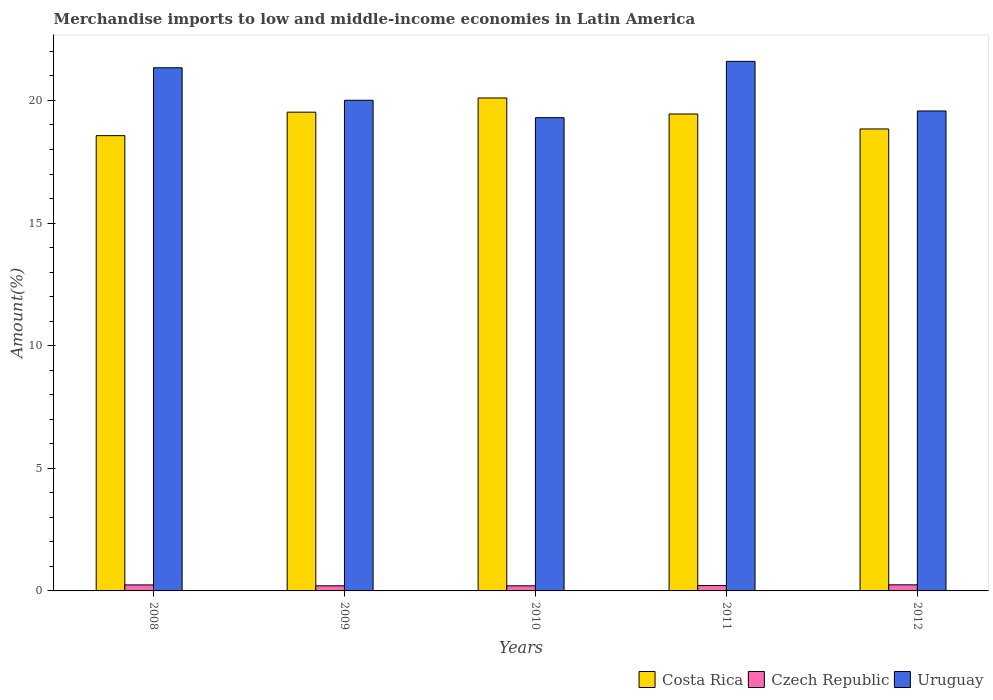How many bars are there on the 4th tick from the left?
Make the answer very short. 3. How many bars are there on the 3rd tick from the right?
Keep it short and to the point. 3. What is the label of the 3rd group of bars from the left?
Your response must be concise. 2010. In how many cases, is the number of bars for a given year not equal to the number of legend labels?
Make the answer very short. 0. What is the percentage of amount earned from merchandise imports in Costa Rica in 2010?
Provide a short and direct response. 20.1. Across all years, what is the maximum percentage of amount earned from merchandise imports in Czech Republic?
Your response must be concise. 0.25. Across all years, what is the minimum percentage of amount earned from merchandise imports in Uruguay?
Provide a short and direct response. 19.3. In which year was the percentage of amount earned from merchandise imports in Costa Rica minimum?
Your response must be concise. 2008. What is the total percentage of amount earned from merchandise imports in Costa Rica in the graph?
Offer a terse response. 96.47. What is the difference between the percentage of amount earned from merchandise imports in Costa Rica in 2011 and that in 2012?
Keep it short and to the point. 0.61. What is the difference between the percentage of amount earned from merchandise imports in Uruguay in 2010 and the percentage of amount earned from merchandise imports in Costa Rica in 2009?
Your answer should be compact. -0.22. What is the average percentage of amount earned from merchandise imports in Costa Rica per year?
Your answer should be compact. 19.29. In the year 2011, what is the difference between the percentage of amount earned from merchandise imports in Costa Rica and percentage of amount earned from merchandise imports in Uruguay?
Provide a succinct answer. -2.15. In how many years, is the percentage of amount earned from merchandise imports in Czech Republic greater than 11 %?
Make the answer very short. 0. What is the ratio of the percentage of amount earned from merchandise imports in Czech Republic in 2011 to that in 2012?
Ensure brevity in your answer.  0.89. Is the percentage of amount earned from merchandise imports in Uruguay in 2011 less than that in 2012?
Offer a terse response. No. What is the difference between the highest and the second highest percentage of amount earned from merchandise imports in Costa Rica?
Your answer should be very brief. 0.58. What is the difference between the highest and the lowest percentage of amount earned from merchandise imports in Costa Rica?
Give a very brief answer. 1.54. In how many years, is the percentage of amount earned from merchandise imports in Uruguay greater than the average percentage of amount earned from merchandise imports in Uruguay taken over all years?
Your response must be concise. 2. What does the 3rd bar from the left in 2012 represents?
Make the answer very short. Uruguay. What does the 2nd bar from the right in 2009 represents?
Your answer should be very brief. Czech Republic. Is it the case that in every year, the sum of the percentage of amount earned from merchandise imports in Costa Rica and percentage of amount earned from merchandise imports in Uruguay is greater than the percentage of amount earned from merchandise imports in Czech Republic?
Provide a succinct answer. Yes. How many bars are there?
Keep it short and to the point. 15. Are all the bars in the graph horizontal?
Your answer should be very brief. No. How many legend labels are there?
Your answer should be very brief. 3. What is the title of the graph?
Give a very brief answer. Merchandise imports to low and middle-income economies in Latin America. What is the label or title of the Y-axis?
Offer a very short reply. Amount(%). What is the Amount(%) in Costa Rica in 2008?
Offer a very short reply. 18.56. What is the Amount(%) in Czech Republic in 2008?
Give a very brief answer. 0.24. What is the Amount(%) of Uruguay in 2008?
Make the answer very short. 21.33. What is the Amount(%) in Costa Rica in 2009?
Keep it short and to the point. 19.52. What is the Amount(%) of Czech Republic in 2009?
Your response must be concise. 0.21. What is the Amount(%) in Uruguay in 2009?
Ensure brevity in your answer.  20.01. What is the Amount(%) of Costa Rica in 2010?
Keep it short and to the point. 20.1. What is the Amount(%) in Czech Republic in 2010?
Your response must be concise. 0.21. What is the Amount(%) of Uruguay in 2010?
Offer a terse response. 19.3. What is the Amount(%) in Costa Rica in 2011?
Your response must be concise. 19.45. What is the Amount(%) in Czech Republic in 2011?
Ensure brevity in your answer.  0.22. What is the Amount(%) of Uruguay in 2011?
Offer a very short reply. 21.59. What is the Amount(%) of Costa Rica in 2012?
Provide a short and direct response. 18.84. What is the Amount(%) in Czech Republic in 2012?
Your answer should be compact. 0.25. What is the Amount(%) in Uruguay in 2012?
Your answer should be compact. 19.57. Across all years, what is the maximum Amount(%) in Costa Rica?
Provide a short and direct response. 20.1. Across all years, what is the maximum Amount(%) of Czech Republic?
Your response must be concise. 0.25. Across all years, what is the maximum Amount(%) in Uruguay?
Make the answer very short. 21.59. Across all years, what is the minimum Amount(%) in Costa Rica?
Keep it short and to the point. 18.56. Across all years, what is the minimum Amount(%) of Czech Republic?
Your response must be concise. 0.21. Across all years, what is the minimum Amount(%) of Uruguay?
Give a very brief answer. 19.3. What is the total Amount(%) of Costa Rica in the graph?
Give a very brief answer. 96.47. What is the total Amount(%) in Czech Republic in the graph?
Provide a succinct answer. 1.13. What is the total Amount(%) in Uruguay in the graph?
Offer a very short reply. 101.8. What is the difference between the Amount(%) in Costa Rica in 2008 and that in 2009?
Offer a terse response. -0.96. What is the difference between the Amount(%) in Czech Republic in 2008 and that in 2009?
Your answer should be compact. 0.04. What is the difference between the Amount(%) of Uruguay in 2008 and that in 2009?
Keep it short and to the point. 1.33. What is the difference between the Amount(%) in Costa Rica in 2008 and that in 2010?
Offer a terse response. -1.54. What is the difference between the Amount(%) in Czech Republic in 2008 and that in 2010?
Your answer should be compact. 0.04. What is the difference between the Amount(%) of Uruguay in 2008 and that in 2010?
Your answer should be compact. 2.04. What is the difference between the Amount(%) in Costa Rica in 2008 and that in 2011?
Ensure brevity in your answer.  -0.88. What is the difference between the Amount(%) of Czech Republic in 2008 and that in 2011?
Your answer should be very brief. 0.02. What is the difference between the Amount(%) in Uruguay in 2008 and that in 2011?
Provide a short and direct response. -0.26. What is the difference between the Amount(%) in Costa Rica in 2008 and that in 2012?
Offer a terse response. -0.27. What is the difference between the Amount(%) in Czech Republic in 2008 and that in 2012?
Keep it short and to the point. -0. What is the difference between the Amount(%) in Uruguay in 2008 and that in 2012?
Provide a short and direct response. 1.76. What is the difference between the Amount(%) in Costa Rica in 2009 and that in 2010?
Give a very brief answer. -0.58. What is the difference between the Amount(%) of Czech Republic in 2009 and that in 2010?
Give a very brief answer. 0. What is the difference between the Amount(%) in Uruguay in 2009 and that in 2010?
Give a very brief answer. 0.71. What is the difference between the Amount(%) in Costa Rica in 2009 and that in 2011?
Keep it short and to the point. 0.07. What is the difference between the Amount(%) in Czech Republic in 2009 and that in 2011?
Ensure brevity in your answer.  -0.01. What is the difference between the Amount(%) of Uruguay in 2009 and that in 2011?
Ensure brevity in your answer.  -1.59. What is the difference between the Amount(%) of Costa Rica in 2009 and that in 2012?
Provide a succinct answer. 0.68. What is the difference between the Amount(%) in Czech Republic in 2009 and that in 2012?
Your answer should be very brief. -0.04. What is the difference between the Amount(%) in Uruguay in 2009 and that in 2012?
Ensure brevity in your answer.  0.44. What is the difference between the Amount(%) in Costa Rica in 2010 and that in 2011?
Keep it short and to the point. 0.65. What is the difference between the Amount(%) of Czech Republic in 2010 and that in 2011?
Make the answer very short. -0.01. What is the difference between the Amount(%) in Uruguay in 2010 and that in 2011?
Keep it short and to the point. -2.3. What is the difference between the Amount(%) in Costa Rica in 2010 and that in 2012?
Offer a terse response. 1.26. What is the difference between the Amount(%) of Czech Republic in 2010 and that in 2012?
Your answer should be compact. -0.04. What is the difference between the Amount(%) in Uruguay in 2010 and that in 2012?
Your answer should be very brief. -0.27. What is the difference between the Amount(%) of Costa Rica in 2011 and that in 2012?
Keep it short and to the point. 0.61. What is the difference between the Amount(%) of Czech Republic in 2011 and that in 2012?
Give a very brief answer. -0.03. What is the difference between the Amount(%) in Uruguay in 2011 and that in 2012?
Ensure brevity in your answer.  2.02. What is the difference between the Amount(%) in Costa Rica in 2008 and the Amount(%) in Czech Republic in 2009?
Provide a short and direct response. 18.36. What is the difference between the Amount(%) of Costa Rica in 2008 and the Amount(%) of Uruguay in 2009?
Provide a short and direct response. -1.44. What is the difference between the Amount(%) in Czech Republic in 2008 and the Amount(%) in Uruguay in 2009?
Provide a short and direct response. -19.76. What is the difference between the Amount(%) in Costa Rica in 2008 and the Amount(%) in Czech Republic in 2010?
Your answer should be compact. 18.36. What is the difference between the Amount(%) in Costa Rica in 2008 and the Amount(%) in Uruguay in 2010?
Provide a succinct answer. -0.73. What is the difference between the Amount(%) of Czech Republic in 2008 and the Amount(%) of Uruguay in 2010?
Ensure brevity in your answer.  -19.05. What is the difference between the Amount(%) in Costa Rica in 2008 and the Amount(%) in Czech Republic in 2011?
Ensure brevity in your answer.  18.34. What is the difference between the Amount(%) in Costa Rica in 2008 and the Amount(%) in Uruguay in 2011?
Keep it short and to the point. -3.03. What is the difference between the Amount(%) in Czech Republic in 2008 and the Amount(%) in Uruguay in 2011?
Ensure brevity in your answer.  -21.35. What is the difference between the Amount(%) of Costa Rica in 2008 and the Amount(%) of Czech Republic in 2012?
Your response must be concise. 18.32. What is the difference between the Amount(%) of Costa Rica in 2008 and the Amount(%) of Uruguay in 2012?
Offer a very short reply. -1.01. What is the difference between the Amount(%) of Czech Republic in 2008 and the Amount(%) of Uruguay in 2012?
Offer a very short reply. -19.33. What is the difference between the Amount(%) of Costa Rica in 2009 and the Amount(%) of Czech Republic in 2010?
Provide a succinct answer. 19.31. What is the difference between the Amount(%) of Costa Rica in 2009 and the Amount(%) of Uruguay in 2010?
Offer a very short reply. 0.22. What is the difference between the Amount(%) of Czech Republic in 2009 and the Amount(%) of Uruguay in 2010?
Your answer should be compact. -19.09. What is the difference between the Amount(%) in Costa Rica in 2009 and the Amount(%) in Czech Republic in 2011?
Provide a short and direct response. 19.3. What is the difference between the Amount(%) of Costa Rica in 2009 and the Amount(%) of Uruguay in 2011?
Give a very brief answer. -2.07. What is the difference between the Amount(%) in Czech Republic in 2009 and the Amount(%) in Uruguay in 2011?
Give a very brief answer. -21.38. What is the difference between the Amount(%) in Costa Rica in 2009 and the Amount(%) in Czech Republic in 2012?
Your answer should be very brief. 19.27. What is the difference between the Amount(%) in Costa Rica in 2009 and the Amount(%) in Uruguay in 2012?
Your answer should be very brief. -0.05. What is the difference between the Amount(%) in Czech Republic in 2009 and the Amount(%) in Uruguay in 2012?
Offer a very short reply. -19.36. What is the difference between the Amount(%) in Costa Rica in 2010 and the Amount(%) in Czech Republic in 2011?
Offer a very short reply. 19.88. What is the difference between the Amount(%) in Costa Rica in 2010 and the Amount(%) in Uruguay in 2011?
Your answer should be compact. -1.49. What is the difference between the Amount(%) in Czech Republic in 2010 and the Amount(%) in Uruguay in 2011?
Your answer should be very brief. -21.39. What is the difference between the Amount(%) of Costa Rica in 2010 and the Amount(%) of Czech Republic in 2012?
Give a very brief answer. 19.85. What is the difference between the Amount(%) in Costa Rica in 2010 and the Amount(%) in Uruguay in 2012?
Ensure brevity in your answer.  0.53. What is the difference between the Amount(%) of Czech Republic in 2010 and the Amount(%) of Uruguay in 2012?
Offer a terse response. -19.36. What is the difference between the Amount(%) in Costa Rica in 2011 and the Amount(%) in Czech Republic in 2012?
Ensure brevity in your answer.  19.2. What is the difference between the Amount(%) in Costa Rica in 2011 and the Amount(%) in Uruguay in 2012?
Provide a succinct answer. -0.12. What is the difference between the Amount(%) of Czech Republic in 2011 and the Amount(%) of Uruguay in 2012?
Provide a succinct answer. -19.35. What is the average Amount(%) of Costa Rica per year?
Your response must be concise. 19.29. What is the average Amount(%) of Czech Republic per year?
Provide a succinct answer. 0.23. What is the average Amount(%) in Uruguay per year?
Keep it short and to the point. 20.36. In the year 2008, what is the difference between the Amount(%) of Costa Rica and Amount(%) of Czech Republic?
Ensure brevity in your answer.  18.32. In the year 2008, what is the difference between the Amount(%) of Costa Rica and Amount(%) of Uruguay?
Your answer should be very brief. -2.77. In the year 2008, what is the difference between the Amount(%) of Czech Republic and Amount(%) of Uruguay?
Your answer should be compact. -21.09. In the year 2009, what is the difference between the Amount(%) of Costa Rica and Amount(%) of Czech Republic?
Offer a terse response. 19.31. In the year 2009, what is the difference between the Amount(%) of Costa Rica and Amount(%) of Uruguay?
Make the answer very short. -0.49. In the year 2009, what is the difference between the Amount(%) of Czech Republic and Amount(%) of Uruguay?
Make the answer very short. -19.8. In the year 2010, what is the difference between the Amount(%) in Costa Rica and Amount(%) in Czech Republic?
Your response must be concise. 19.89. In the year 2010, what is the difference between the Amount(%) of Costa Rica and Amount(%) of Uruguay?
Give a very brief answer. 0.8. In the year 2010, what is the difference between the Amount(%) in Czech Republic and Amount(%) in Uruguay?
Offer a terse response. -19.09. In the year 2011, what is the difference between the Amount(%) in Costa Rica and Amount(%) in Czech Republic?
Provide a succinct answer. 19.23. In the year 2011, what is the difference between the Amount(%) in Costa Rica and Amount(%) in Uruguay?
Your response must be concise. -2.15. In the year 2011, what is the difference between the Amount(%) of Czech Republic and Amount(%) of Uruguay?
Keep it short and to the point. -21.37. In the year 2012, what is the difference between the Amount(%) in Costa Rica and Amount(%) in Czech Republic?
Offer a very short reply. 18.59. In the year 2012, what is the difference between the Amount(%) of Costa Rica and Amount(%) of Uruguay?
Offer a terse response. -0.73. In the year 2012, what is the difference between the Amount(%) in Czech Republic and Amount(%) in Uruguay?
Give a very brief answer. -19.32. What is the ratio of the Amount(%) in Costa Rica in 2008 to that in 2009?
Keep it short and to the point. 0.95. What is the ratio of the Amount(%) in Czech Republic in 2008 to that in 2009?
Provide a short and direct response. 1.17. What is the ratio of the Amount(%) in Uruguay in 2008 to that in 2009?
Your answer should be very brief. 1.07. What is the ratio of the Amount(%) in Costa Rica in 2008 to that in 2010?
Your answer should be very brief. 0.92. What is the ratio of the Amount(%) of Czech Republic in 2008 to that in 2010?
Offer a very short reply. 1.18. What is the ratio of the Amount(%) of Uruguay in 2008 to that in 2010?
Keep it short and to the point. 1.11. What is the ratio of the Amount(%) in Costa Rica in 2008 to that in 2011?
Offer a terse response. 0.95. What is the ratio of the Amount(%) in Czech Republic in 2008 to that in 2011?
Keep it short and to the point. 1.11. What is the ratio of the Amount(%) in Uruguay in 2008 to that in 2011?
Keep it short and to the point. 0.99. What is the ratio of the Amount(%) of Costa Rica in 2008 to that in 2012?
Your answer should be compact. 0.99. What is the ratio of the Amount(%) in Czech Republic in 2008 to that in 2012?
Provide a succinct answer. 0.99. What is the ratio of the Amount(%) in Uruguay in 2008 to that in 2012?
Provide a succinct answer. 1.09. What is the ratio of the Amount(%) in Costa Rica in 2009 to that in 2010?
Ensure brevity in your answer.  0.97. What is the ratio of the Amount(%) of Uruguay in 2009 to that in 2010?
Give a very brief answer. 1.04. What is the ratio of the Amount(%) in Costa Rica in 2009 to that in 2011?
Make the answer very short. 1. What is the ratio of the Amount(%) in Czech Republic in 2009 to that in 2011?
Keep it short and to the point. 0.95. What is the ratio of the Amount(%) of Uruguay in 2009 to that in 2011?
Provide a succinct answer. 0.93. What is the ratio of the Amount(%) in Costa Rica in 2009 to that in 2012?
Your answer should be very brief. 1.04. What is the ratio of the Amount(%) of Czech Republic in 2009 to that in 2012?
Your answer should be compact. 0.84. What is the ratio of the Amount(%) of Uruguay in 2009 to that in 2012?
Give a very brief answer. 1.02. What is the ratio of the Amount(%) in Costa Rica in 2010 to that in 2011?
Your response must be concise. 1.03. What is the ratio of the Amount(%) in Czech Republic in 2010 to that in 2011?
Your answer should be very brief. 0.94. What is the ratio of the Amount(%) in Uruguay in 2010 to that in 2011?
Your response must be concise. 0.89. What is the ratio of the Amount(%) in Costa Rica in 2010 to that in 2012?
Provide a succinct answer. 1.07. What is the ratio of the Amount(%) in Czech Republic in 2010 to that in 2012?
Provide a short and direct response. 0.84. What is the ratio of the Amount(%) in Uruguay in 2010 to that in 2012?
Offer a very short reply. 0.99. What is the ratio of the Amount(%) of Costa Rica in 2011 to that in 2012?
Give a very brief answer. 1.03. What is the ratio of the Amount(%) in Czech Republic in 2011 to that in 2012?
Keep it short and to the point. 0.89. What is the ratio of the Amount(%) in Uruguay in 2011 to that in 2012?
Your answer should be very brief. 1.1. What is the difference between the highest and the second highest Amount(%) in Costa Rica?
Provide a short and direct response. 0.58. What is the difference between the highest and the second highest Amount(%) in Czech Republic?
Your answer should be compact. 0. What is the difference between the highest and the second highest Amount(%) in Uruguay?
Ensure brevity in your answer.  0.26. What is the difference between the highest and the lowest Amount(%) of Costa Rica?
Your response must be concise. 1.54. What is the difference between the highest and the lowest Amount(%) in Uruguay?
Your answer should be compact. 2.3. 